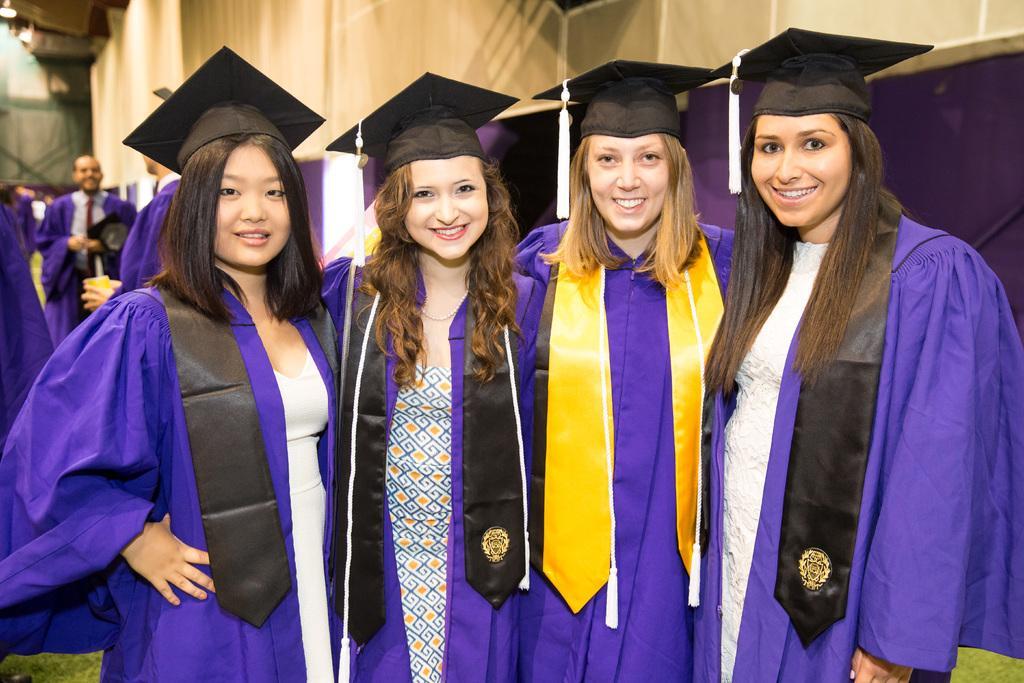How would you summarize this image in a sentence or two? In the background we can see the wall, purple metal panel and objects. In this picture we can see the people wearing graduation gowns and hats. They all are smiling. On the left side of the picture we can see the people. 